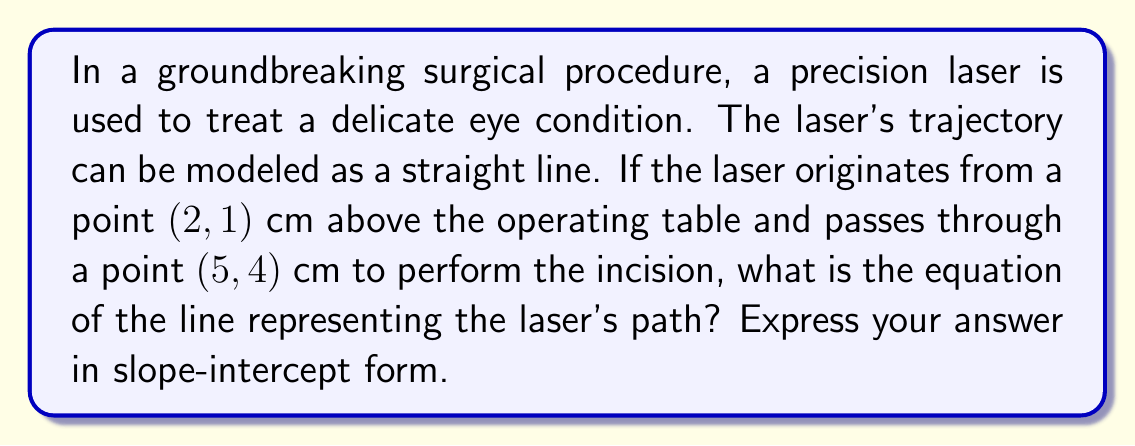Could you help me with this problem? To find the equation of the line representing the laser's trajectory, we'll follow these steps:

1) First, we need to calculate the slope of the line. We can use the slope formula:

   $m = \frac{y_2 - y_1}{x_2 - x_1}$

   Where $(x_1, y_1)$ is the first point (2, 1) and $(x_2, y_2)$ is the second point (5, 4).

2) Plugging in the values:

   $m = \frac{4 - 1}{5 - 2} = \frac{3}{3} = 1$

3) Now that we have the slope, we can use the point-slope form of a line:

   $y - y_1 = m(x - x_1)$

4) Let's use the point (2, 1) and substitute our known values:

   $y - 1 = 1(x - 2)$

5) Simplify:

   $y - 1 = x - 2$

6) Add 1 to both sides to get the equation in slope-intercept form $(y = mx + b)$:

   $y = x - 2 + 1$
   $y = x - 1$

Therefore, the equation of the line representing the laser's trajectory is $y = x - 1$.
Answer: $y = x - 1$ 